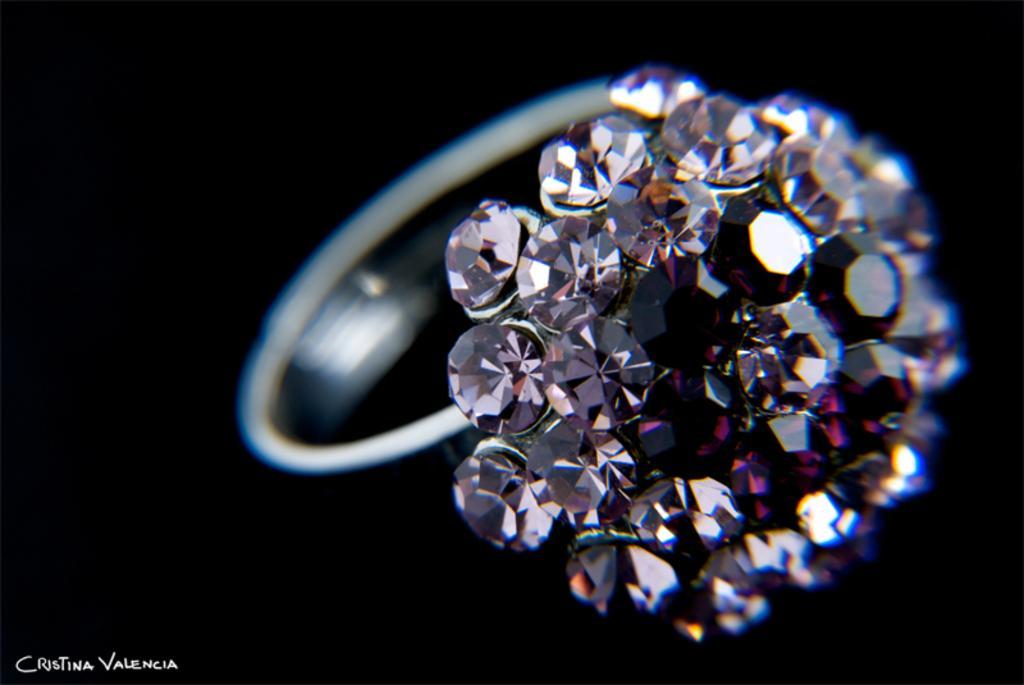Can you describe this image briefly? In this image I can see silver colored ring to which I can see number of diamonds are attached which are white and pink in color. I can see the black colored background. 